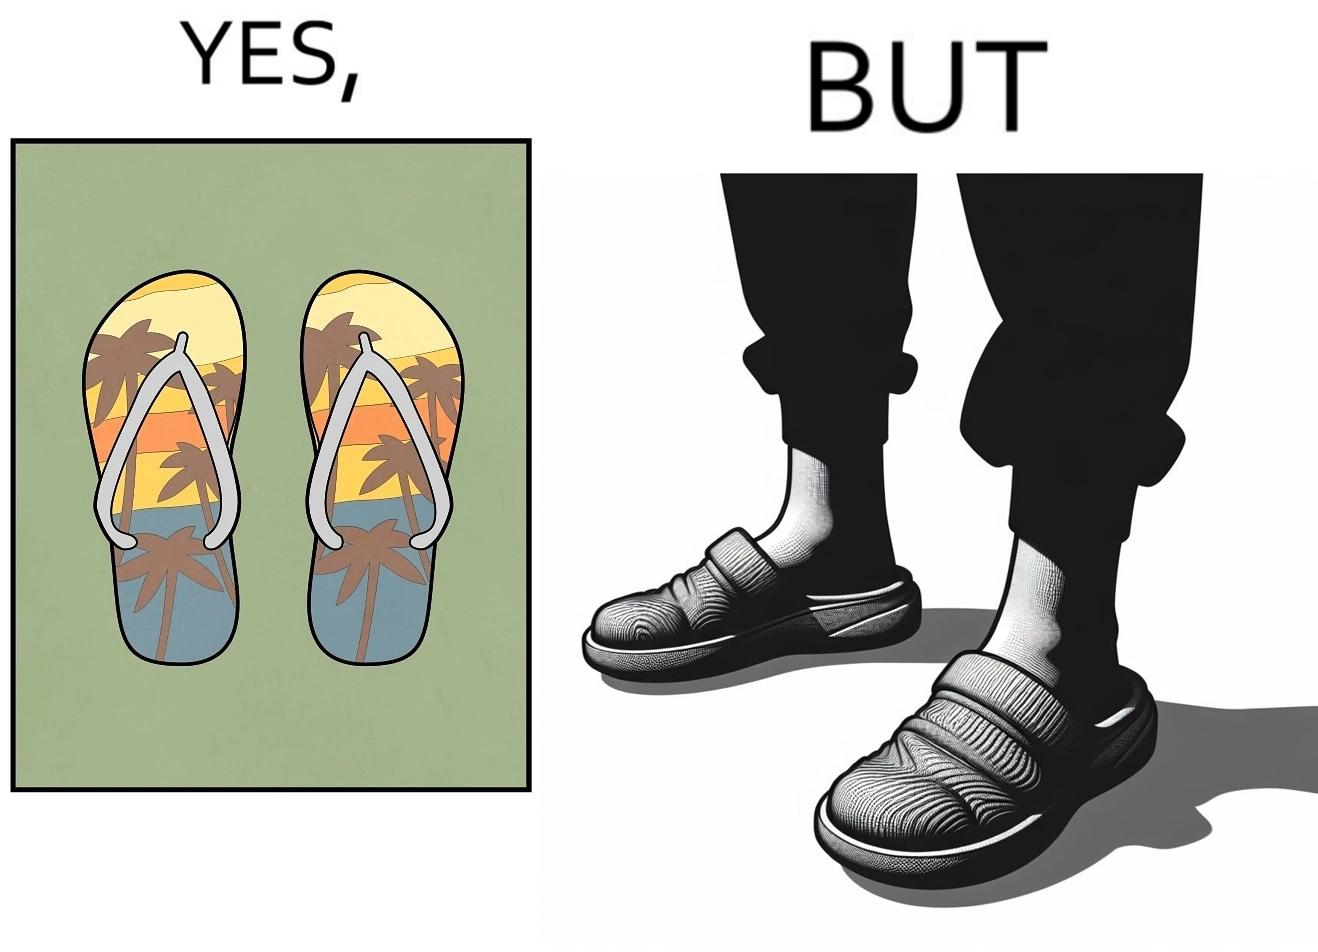What do you see in each half of this image? In the left part of the image: Pair of colorful slippers, having an image of coconut trees probably in a beach by the sea during sunset. In the right part of the image: A person's legs wearing a pair of slippers. 